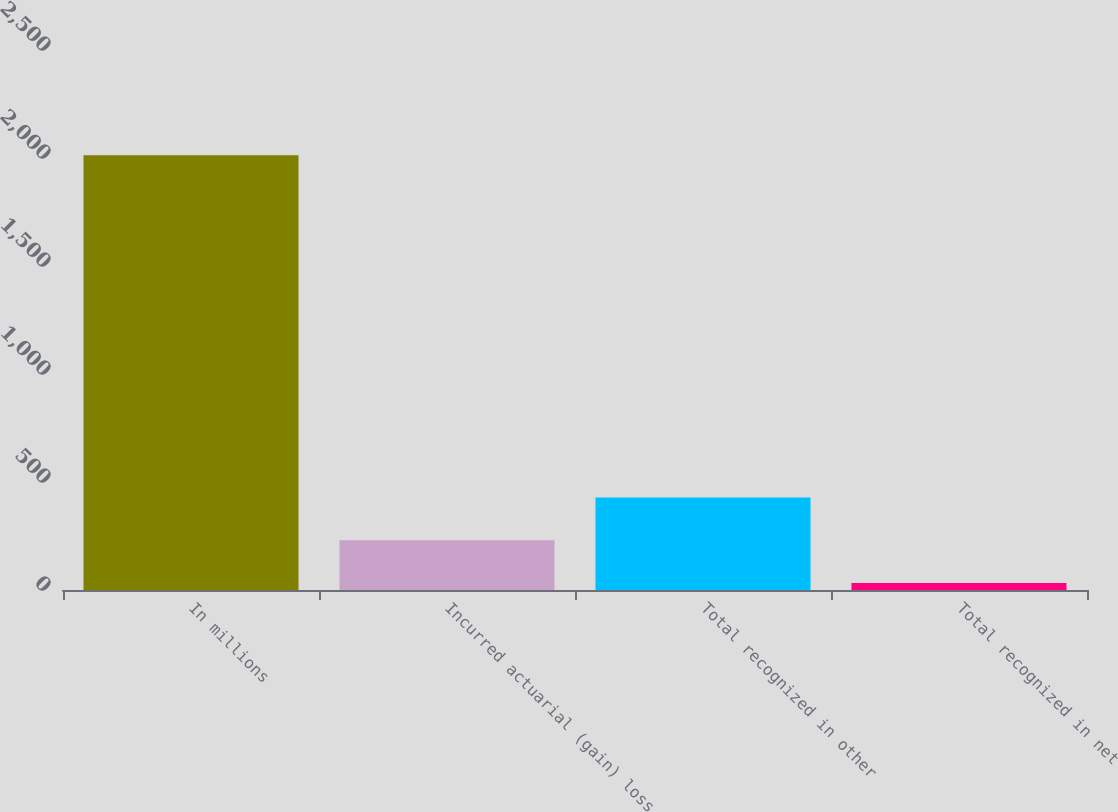<chart> <loc_0><loc_0><loc_500><loc_500><bar_chart><fcel>In millions<fcel>Incurred actuarial (gain) loss<fcel>Total recognized in other<fcel>Total recognized in net<nl><fcel>2013<fcel>230.1<fcel>428.2<fcel>32<nl></chart> 